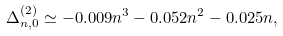Convert formula to latex. <formula><loc_0><loc_0><loc_500><loc_500>\Delta _ { n , 0 } ^ { ( 2 ) } \simeq - 0 . 0 0 9 n ^ { 3 } - 0 . 0 5 2 n ^ { 2 } - 0 . 0 2 5 n ,</formula> 